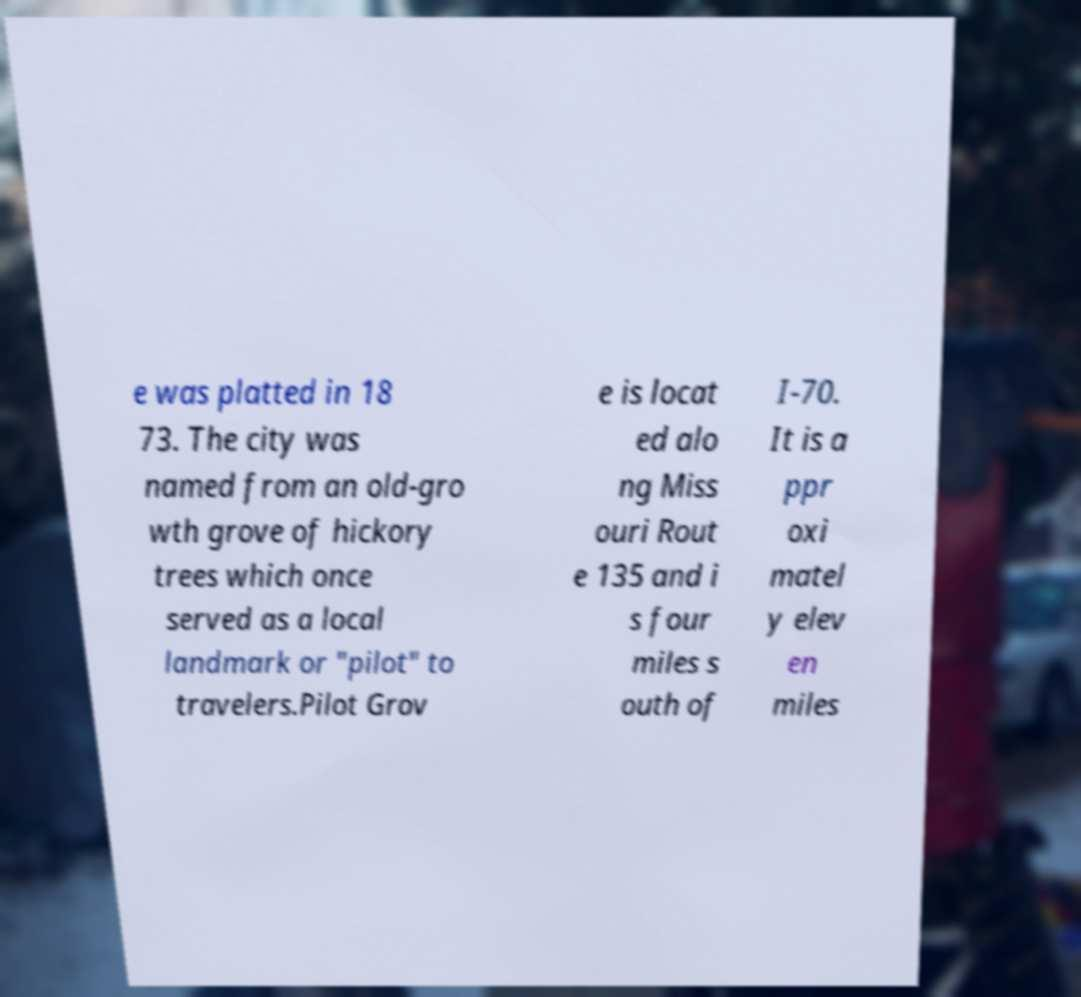Could you extract and type out the text from this image? e was platted in 18 73. The city was named from an old-gro wth grove of hickory trees which once served as a local landmark or "pilot" to travelers.Pilot Grov e is locat ed alo ng Miss ouri Rout e 135 and i s four miles s outh of I-70. It is a ppr oxi matel y elev en miles 